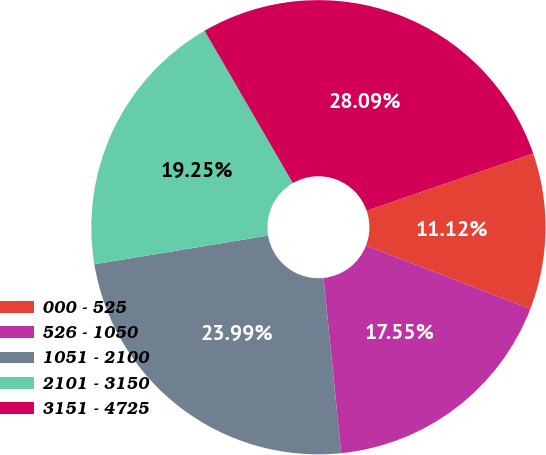Convert chart to OTSL. <chart><loc_0><loc_0><loc_500><loc_500><pie_chart><fcel>000 - 525<fcel>526 - 1050<fcel>1051 - 2100<fcel>2101 - 3150<fcel>3151 - 4725<nl><fcel>11.12%<fcel>17.55%<fcel>23.99%<fcel>19.25%<fcel>28.09%<nl></chart> 